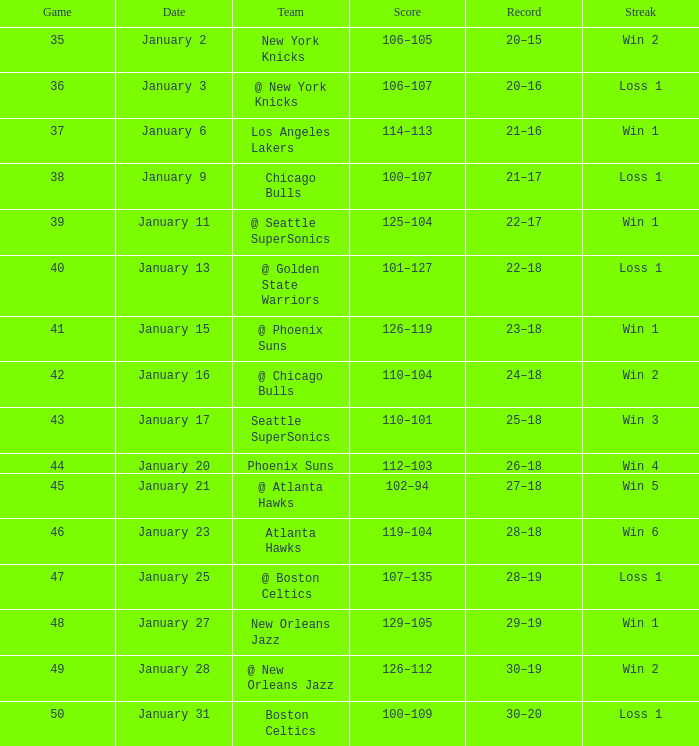What is the Team in Game 41? @ Phoenix Suns. 